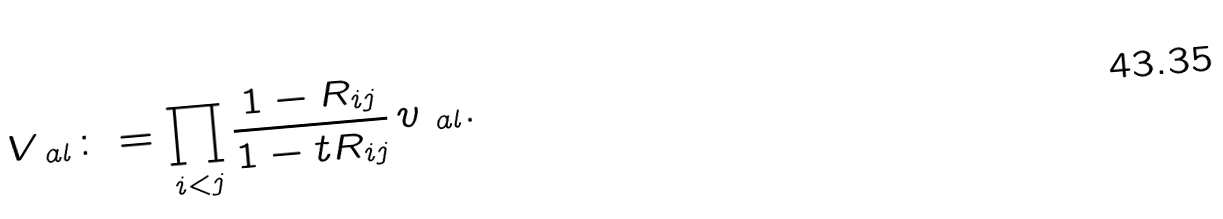<formula> <loc_0><loc_0><loc_500><loc_500>V _ { \ a l } \colon = \prod _ { i < j } \frac { 1 - R _ { i j } } { 1 - t R _ { i j } } \, v _ { \ a l } .</formula> 